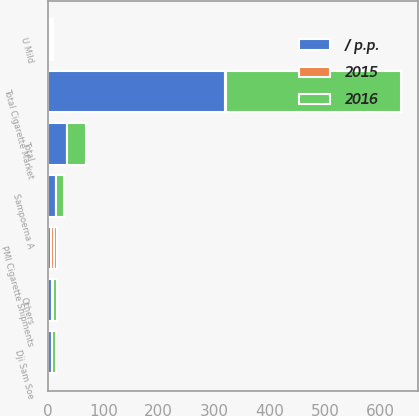Convert chart. <chart><loc_0><loc_0><loc_500><loc_500><stacked_bar_chart><ecel><fcel>Total Cigarette Market<fcel>PMI Cigarette Shipments<fcel>Sampoerna A<fcel>Dji Sam Soe<fcel>U Mild<fcel>Others<fcel>Total<nl><fcel>2016<fcel>315.6<fcel>6.5<fcel>14<fcel>6.5<fcel>4.2<fcel>8.7<fcel>33.4<nl><fcel>/ p.p.<fcel>320<fcel>6.5<fcel>14.6<fcel>6.9<fcel>4.7<fcel>8.1<fcel>34.3<nl><fcel>2015<fcel>1.4<fcel>3.9<fcel>0.6<fcel>0.4<fcel>0.5<fcel>0.6<fcel>0.9<nl></chart> 